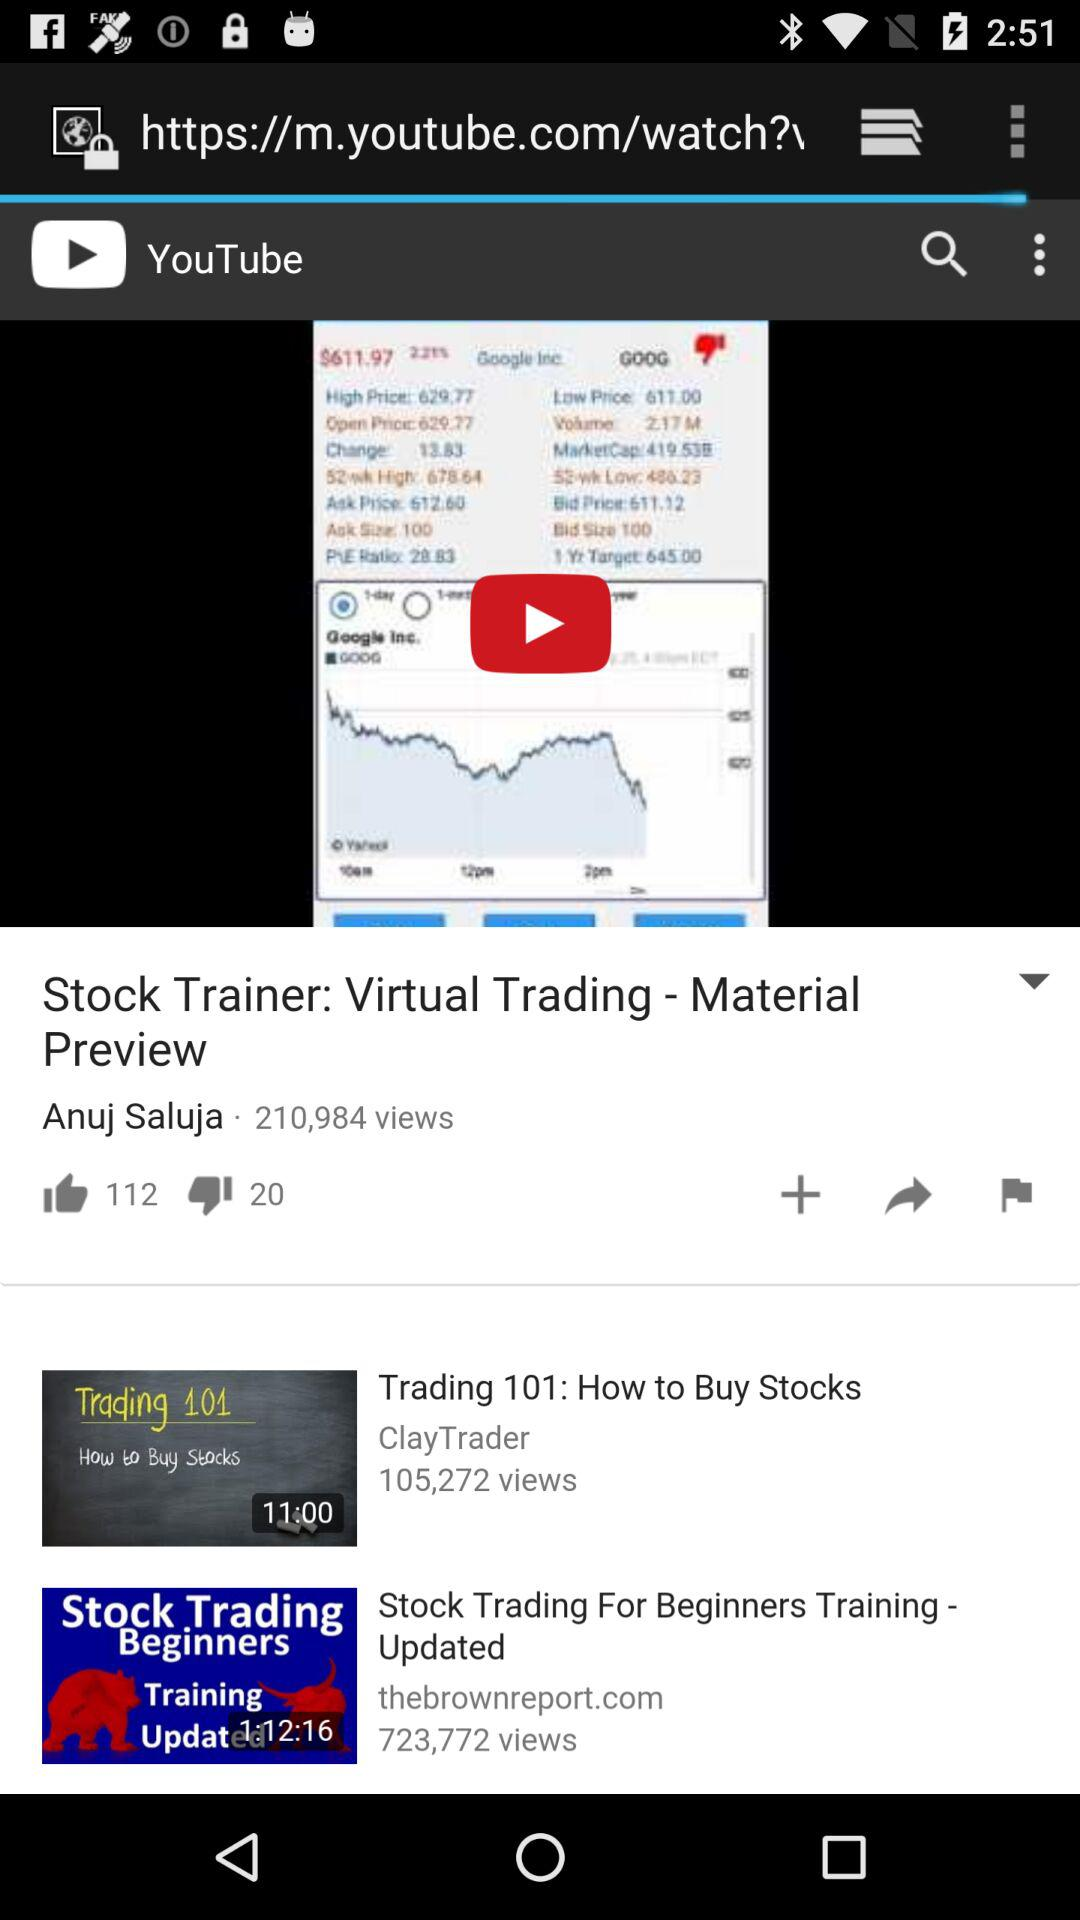What is the channel name of the video "Trading 101: How to Buy Stocks"? The channel name is "ClayTrader". 